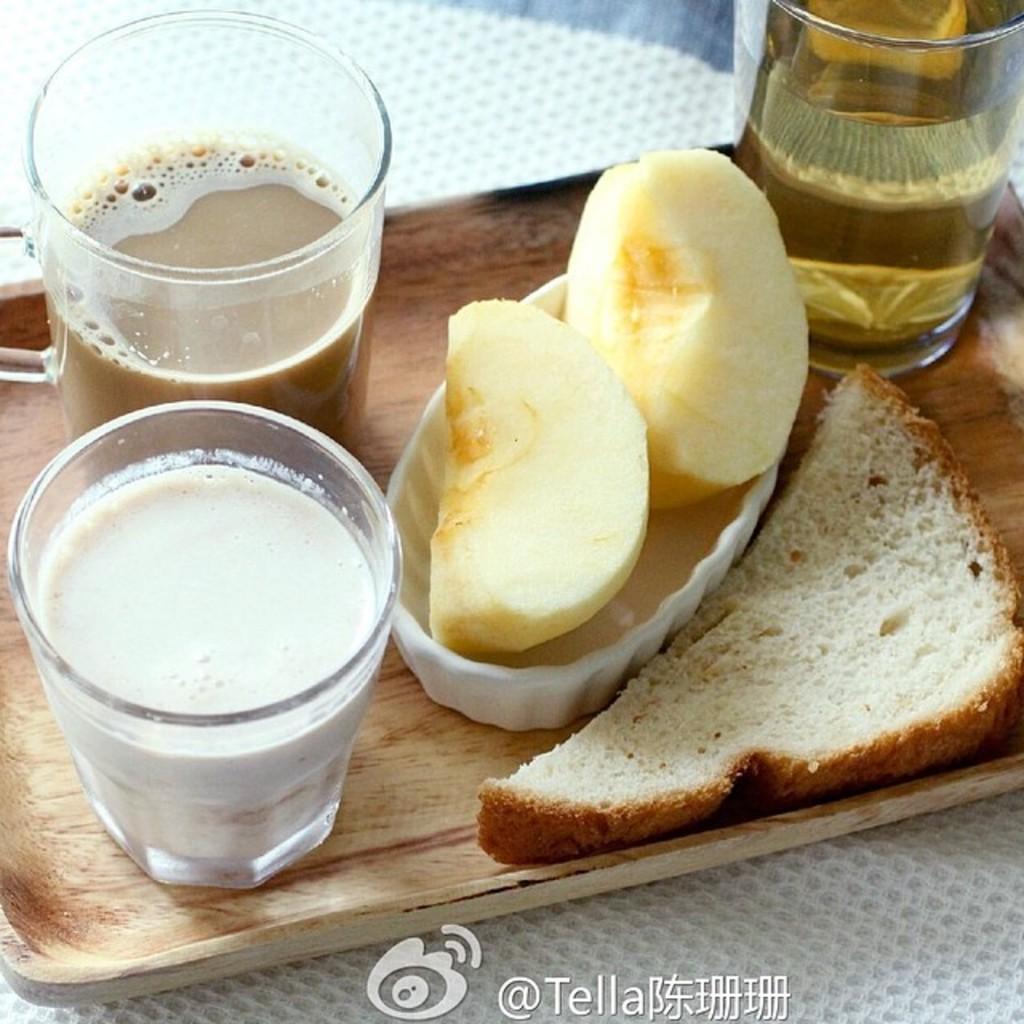How would you summarize this image in a sentence or two? In a tray we can see a piece of bread, apple slices and we can see drinks in the glasses. At the bottom portion of the picture we can see water mark. 